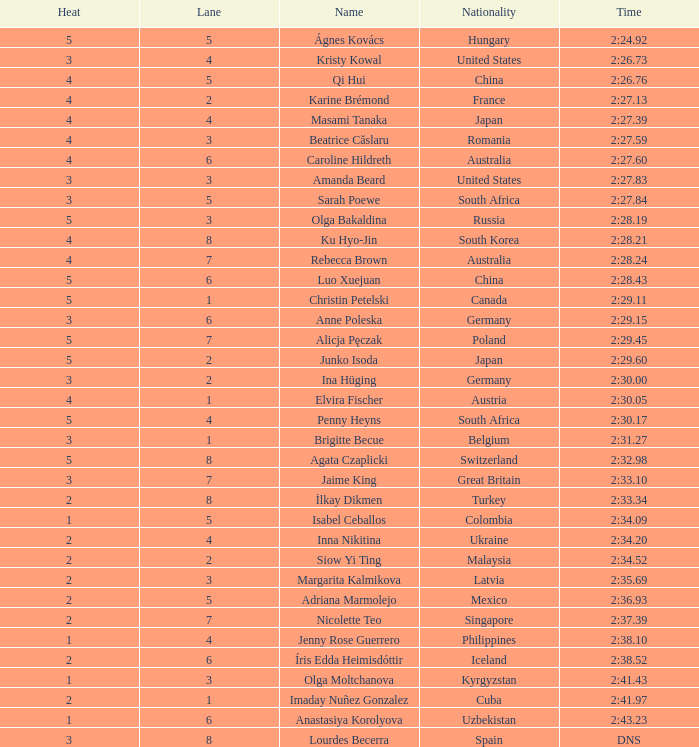What lane did inna nikitina have? 4.0. 